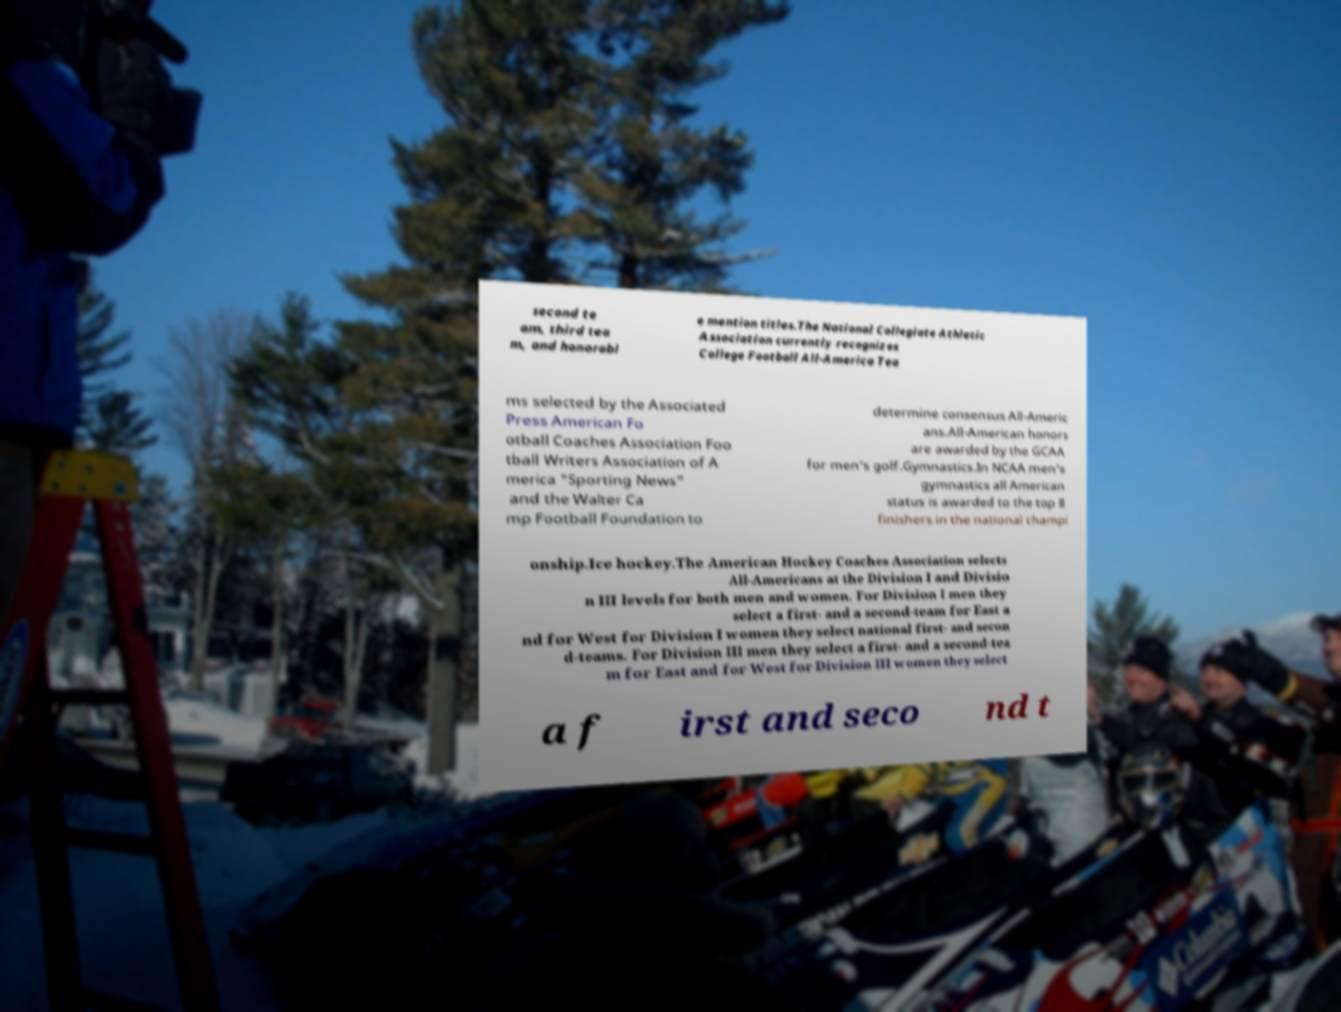I need the written content from this picture converted into text. Can you do that? second te am, third tea m, and honorabl e mention titles.The National Collegiate Athletic Association currently recognizes College Football All-America Tea ms selected by the Associated Press American Fo otball Coaches Association Foo tball Writers Association of A merica "Sporting News" and the Walter Ca mp Football Foundation to determine consensus All-Americ ans.All-American honors are awarded by the GCAA for men's golf.Gymnastics.In NCAA men's gymnastics all American status is awarded to the top 8 finishers in the national champi onship.Ice hockey.The American Hockey Coaches Association selects All-Americans at the Division I and Divisio n III levels for both men and women. For Division I men they select a first- and a second-team for East a nd for West for Division I women they select national first- and secon d-teams. For Division III men they select a first- and a second-tea m for East and for West for Division III women they select a f irst and seco nd t 